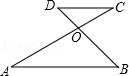How can you use this diagram to explain the alternate interior angles theorem? This diagram is an excellent tool for demonstrating the Alternate Interior Angles Theorem. When two parallel lines like AB and CD are cut by a transversal such as line AC or BD, the alternate interior angles formed (for instance, angles at point O and corresponding angles on the opposite side) are congruent. This geometric setup visually supports that theorem and can be used to prove the equality of these angles using rigid transformations or algebraic methods. 